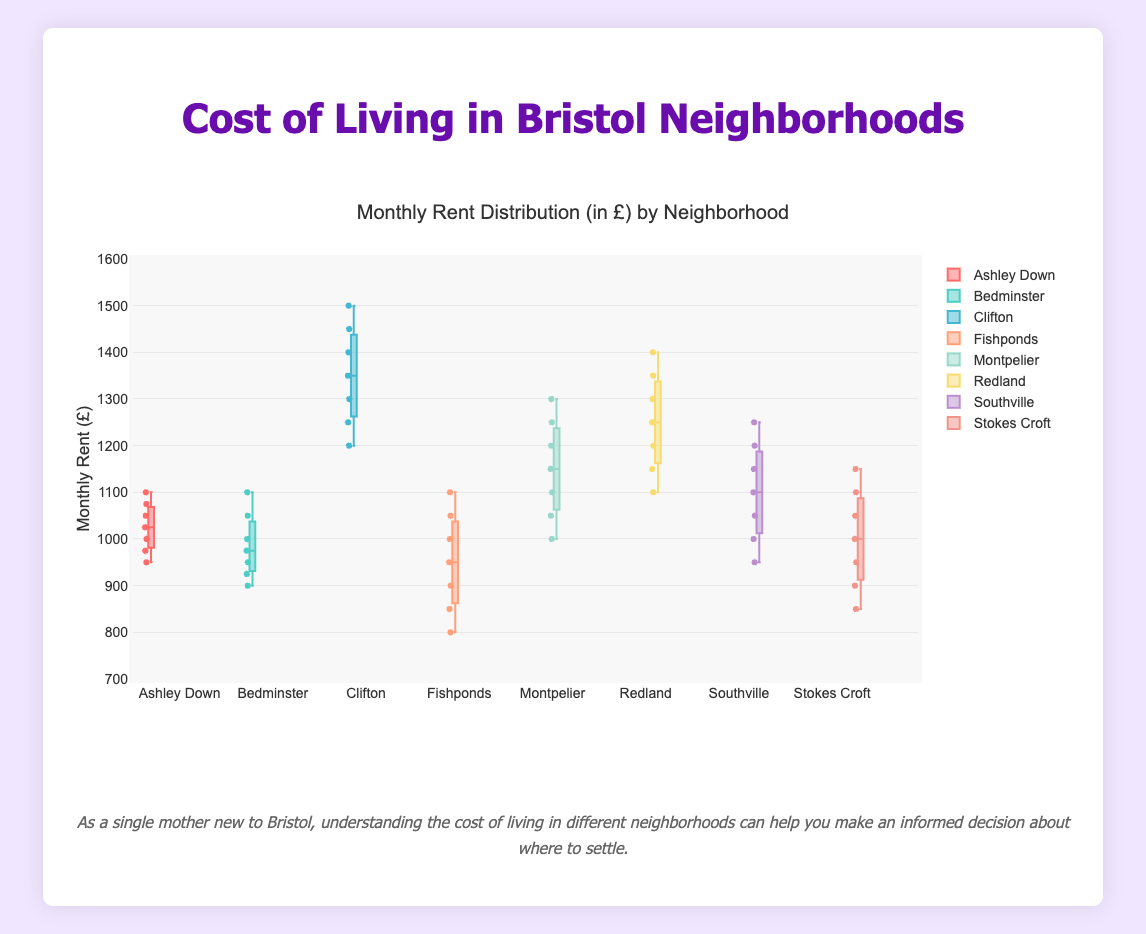What is the title of the box plot? The title of the plot is usually found at the top of the figure, summarizing the content of the graph.
Answer: Monthly Rent Distribution (in £) by Neighborhood Which neighborhood has the highest median rent? Median rent is represented by the line inside the box. By comparing these lines across neighborhoods, the highest median line is found in Clifton.
Answer: Clifton What is the range of rents in Fishponds? The range of rents in a neighborhood is calculated by finding the difference between the maximum and minimum values represented by the whiskers. In Fishponds, the minimum is 800 and the maximum is 1100.
Answer: 300 (£800 - £1100) Which neighborhood has the lowest minimum rent? The minimum rent can be found at the bottom whisker of each box plot. By observing the figure, the lowest minimum rent is in Fishponds.
Answer: Fishponds How does the interquartile range of Bedminster compare to that of Stokes Croft? The interquartile range (IQR) is the difference between the upper quarter and the lower quarter (Q3 - Q1) of the data. Observe the length of the box section for each neighborhood and compare Bedminster's and Stokes Croft's.
Answer: They are similar What are the outlier points in Southville? Outliers are usually marked as individual points outside the whiskers in a box plot. For Southville, there are no points clearly outside the whiskers in the plot.
Answer: None Which neighborhood has the most consistent rent prices? The consistency of rent prices can be analyzed through the size of the box. The smaller the box, the more consistent the rents. Comparing the boxes, Stokes Croft appears to have the most consistent rent prices.
Answer: Stokes Croft In which neighborhood do the rents vary the most? Neighborhoods where the rent prices vary the most have the largest range, seen by the length of the whiskers or the height of the boxes. Clifton has one of the largest ranges, indicating high variability.
Answer: Clifton What is the maximum monthly rent in Ashley Down? The maximum monthly rent is represented by the top whisker in the box plot of Ashley Down. By observing the figure, the top whisker is at 1100.
Answer: 1100 How do the median rents of Montpelier and Redland compare? Median rents are represented by the line inside each box. Comparing these lines for Montpelier and Redland, we see that Redland’s median rent is higher than that of Montpelier.
Answer: Redland is higher 